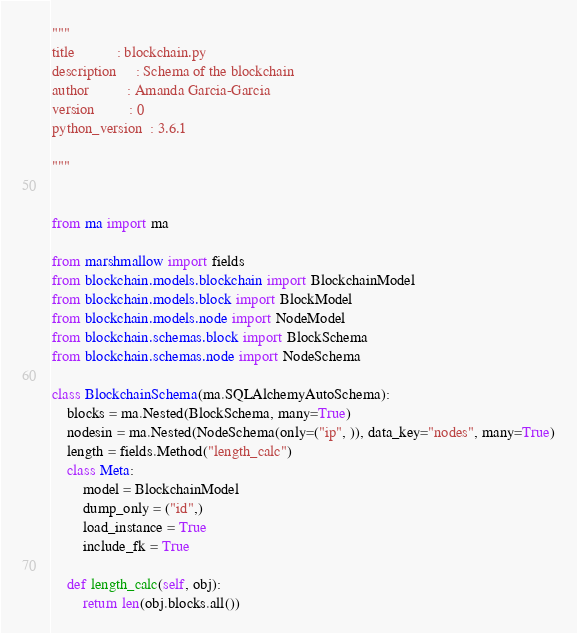Convert code to text. <code><loc_0><loc_0><loc_500><loc_500><_Python_>"""
title           : blockchain.py
description     : Schema of the blockchain
author          : Amanda Garcia-Garcia
version         : 0
python_version  : 3.6.1

"""


from ma import ma

from marshmallow import fields
from blockchain.models.blockchain import BlockchainModel
from blockchain.models.block import BlockModel
from blockchain.models.node import NodeModel
from blockchain.schemas.block import BlockSchema
from blockchain.schemas.node import NodeSchema

class BlockchainSchema(ma.SQLAlchemyAutoSchema):
    blocks = ma.Nested(BlockSchema, many=True)
    nodesin = ma.Nested(NodeSchema(only=("ip", )), data_key="nodes", many=True)
    length = fields.Method("length_calc")
    class Meta:
        model = BlockchainModel
        dump_only = ("id",)
        load_instance = True
        include_fk = True

    def length_calc(self, obj):
        return len(obj.blocks.all())




</code> 